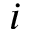<formula> <loc_0><loc_0><loc_500><loc_500>i</formula> 